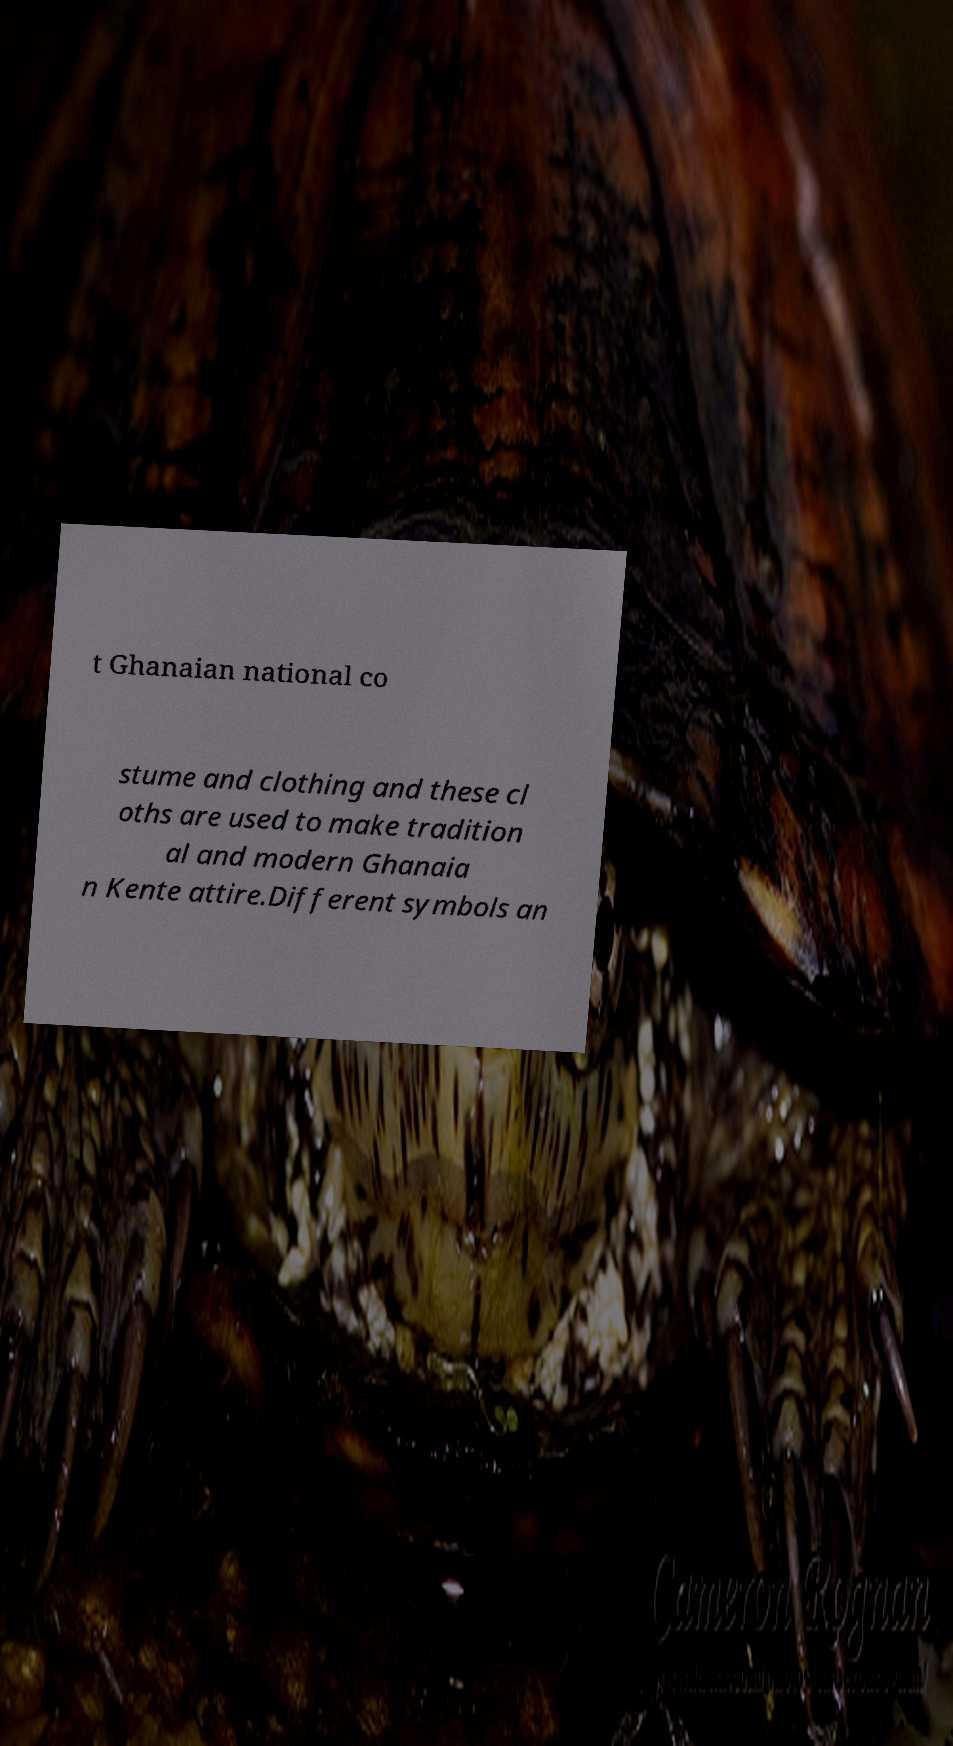For documentation purposes, I need the text within this image transcribed. Could you provide that? t Ghanaian national co stume and clothing and these cl oths are used to make tradition al and modern Ghanaia n Kente attire.Different symbols an 